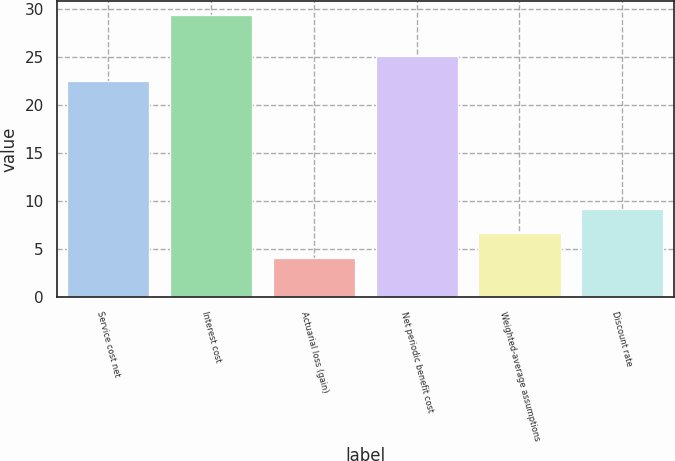Convert chart to OTSL. <chart><loc_0><loc_0><loc_500><loc_500><bar_chart><fcel>Service cost net<fcel>Interest cost<fcel>Actuarial loss (gain)<fcel>Net periodic benefit cost<fcel>Weighted-average assumptions<fcel>Discount rate<nl><fcel>22.5<fcel>29.3<fcel>4.1<fcel>25.02<fcel>6.62<fcel>9.14<nl></chart> 